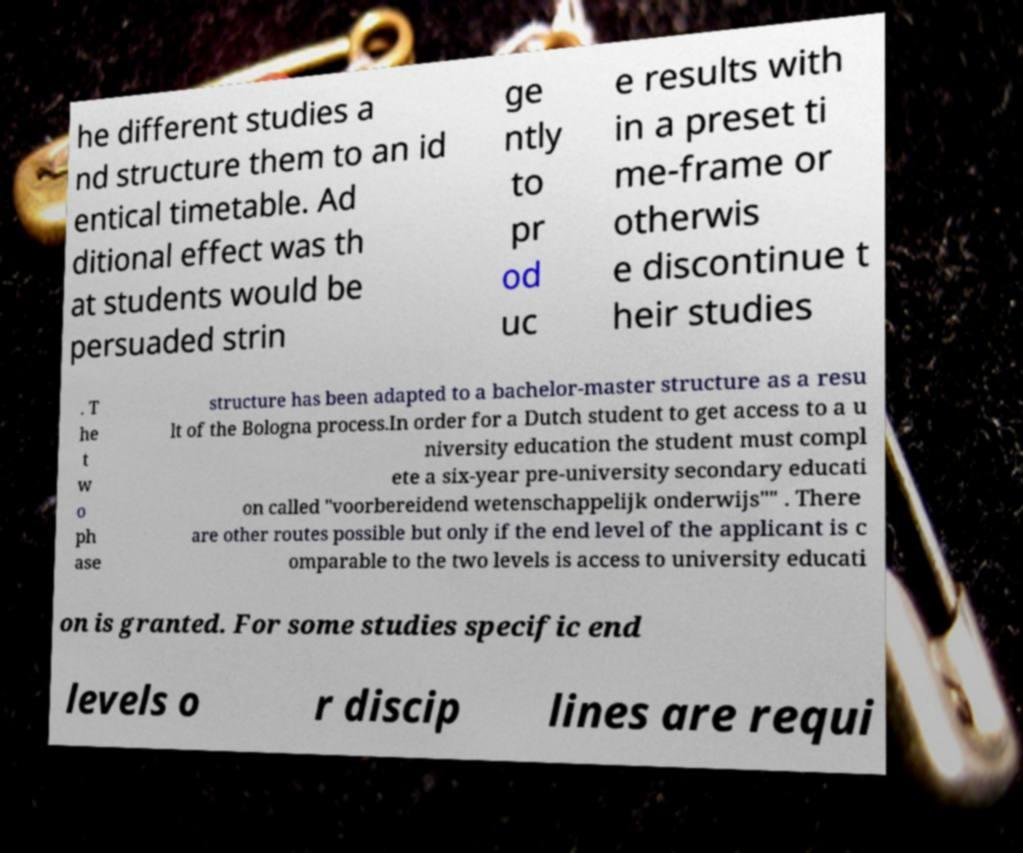Can you read and provide the text displayed in the image?This photo seems to have some interesting text. Can you extract and type it out for me? he different studies a nd structure them to an id entical timetable. Ad ditional effect was th at students would be persuaded strin ge ntly to pr od uc e results with in a preset ti me-frame or otherwis e discontinue t heir studies . T he t w o ph ase structure has been adapted to a bachelor-master structure as a resu lt of the Bologna process.In order for a Dutch student to get access to a u niversity education the student must compl ete a six-year pre-university secondary educati on called "voorbereidend wetenschappelijk onderwijs"" . There are other routes possible but only if the end level of the applicant is c omparable to the two levels is access to university educati on is granted. For some studies specific end levels o r discip lines are requi 